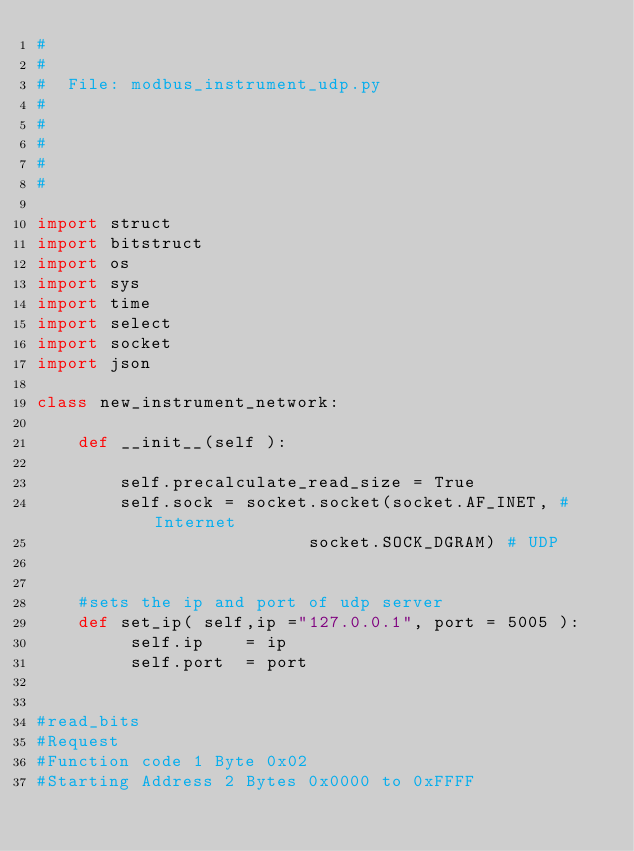Convert code to text. <code><loc_0><loc_0><loc_500><loc_500><_Python_>#
#
#  File: modbus_instrument_udp.py
#
#
#
#
#

import struct    
import bitstruct 
import os
import sys
import time
import select
import socket
import json

class new_instrument_network:
    
    def __init__(self ):

        self.precalculate_read_size = True
        self.sock = socket.socket(socket.AF_INET, # Internet
                          socket.SOCK_DGRAM) # UDP
                          
                          
    #sets the ip and port of udp server
    def set_ip( self,ip ="127.0.0.1", port = 5005 ):
         self.ip    = ip
         self.port  = port
        

#read_bits
#Request
#Function code 1 Byte 0x02
#Starting Address 2 Bytes 0x0000 to 0xFFFF</code> 